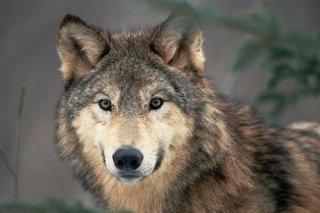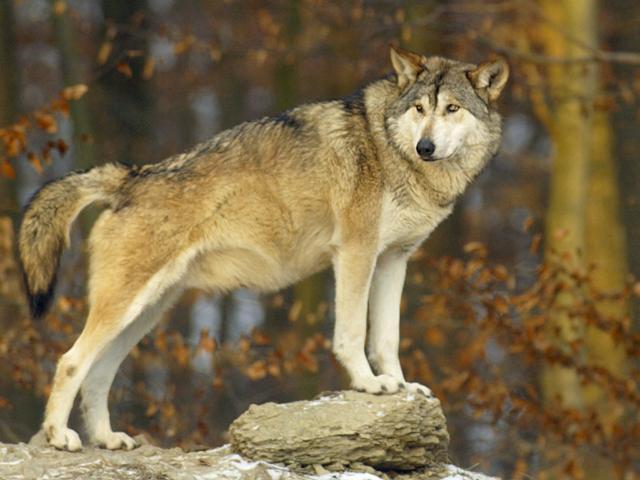The first image is the image on the left, the second image is the image on the right. Given the left and right images, does the statement "At least one wolfe has their body positioned toward the right." hold true? Answer yes or no. Yes. 